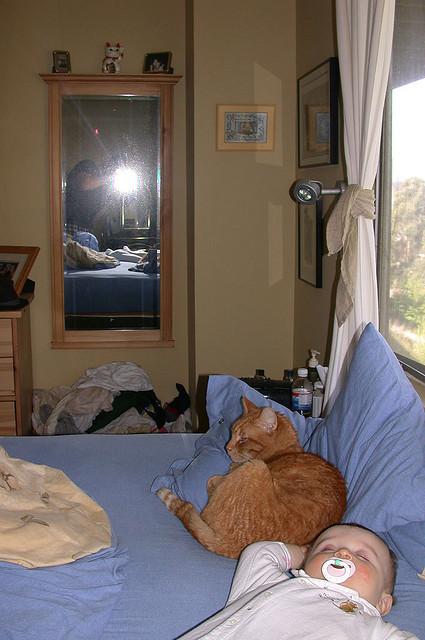What animal is on the bed?
Be succinct. Cat. What animal is next to the kid?
Short answer required. Cat. Is a mirror made of sand?
Be succinct. No. Where is the cat and the baby?
Answer briefly. Bed. Is this cat extremely uncomfortable?
Short answer required. No. 